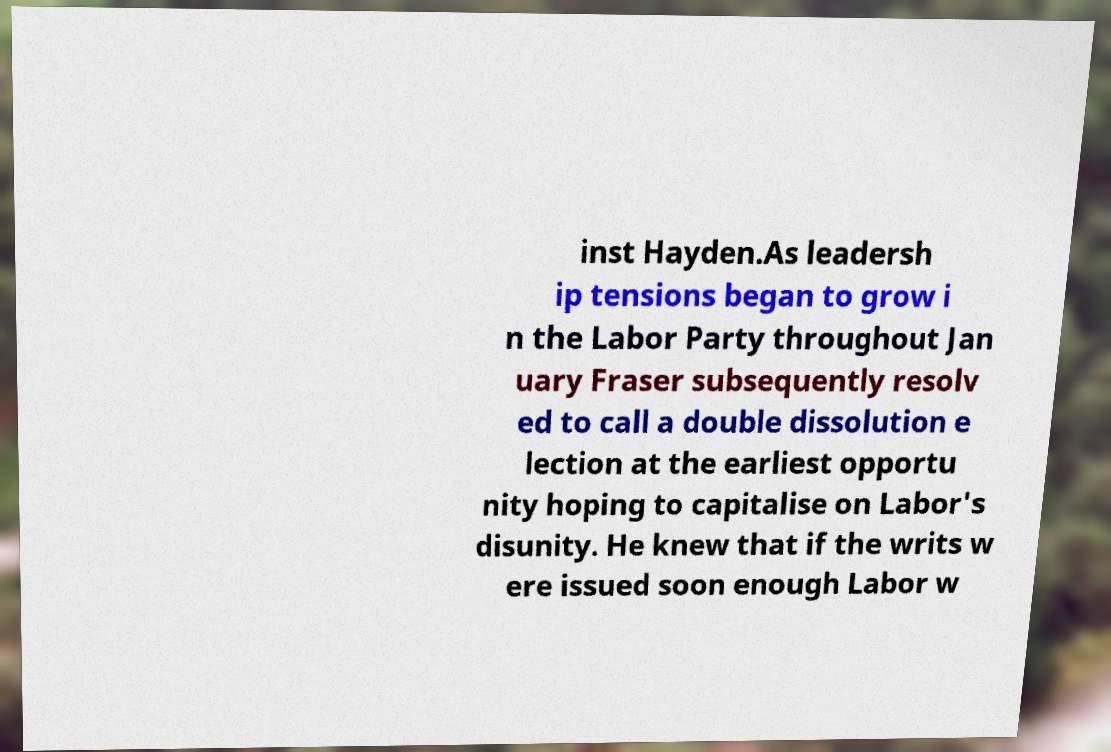Could you assist in decoding the text presented in this image and type it out clearly? inst Hayden.As leadersh ip tensions began to grow i n the Labor Party throughout Jan uary Fraser subsequently resolv ed to call a double dissolution e lection at the earliest opportu nity hoping to capitalise on Labor's disunity. He knew that if the writs w ere issued soon enough Labor w 